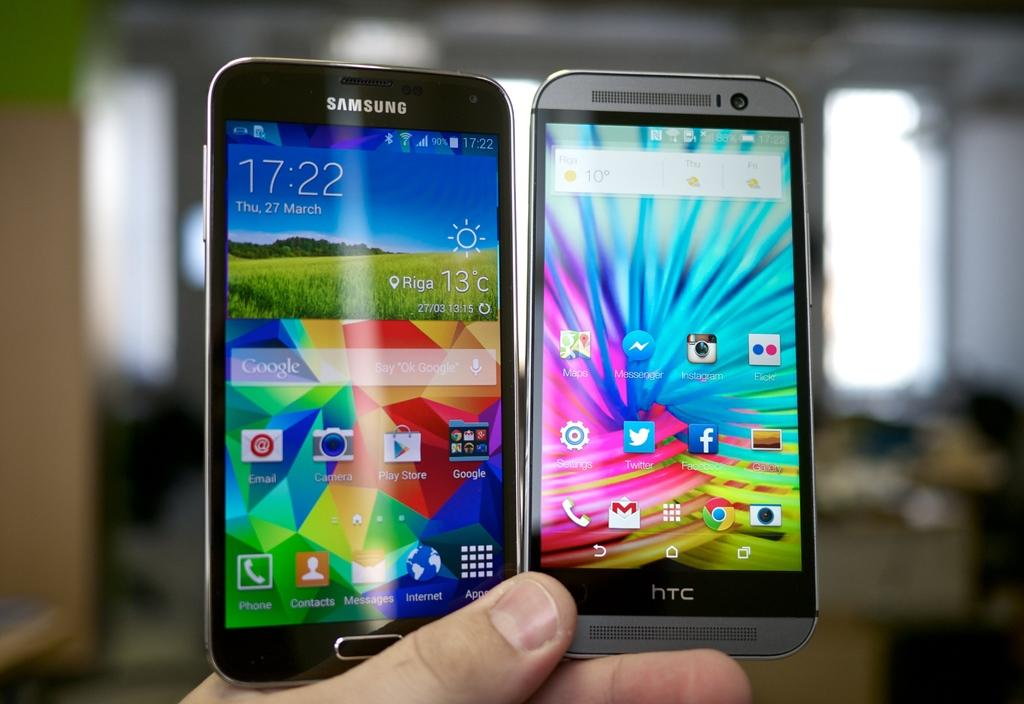<image>
Provide a brief description of the given image. Two cell phones are made by HTC and Samsung. 